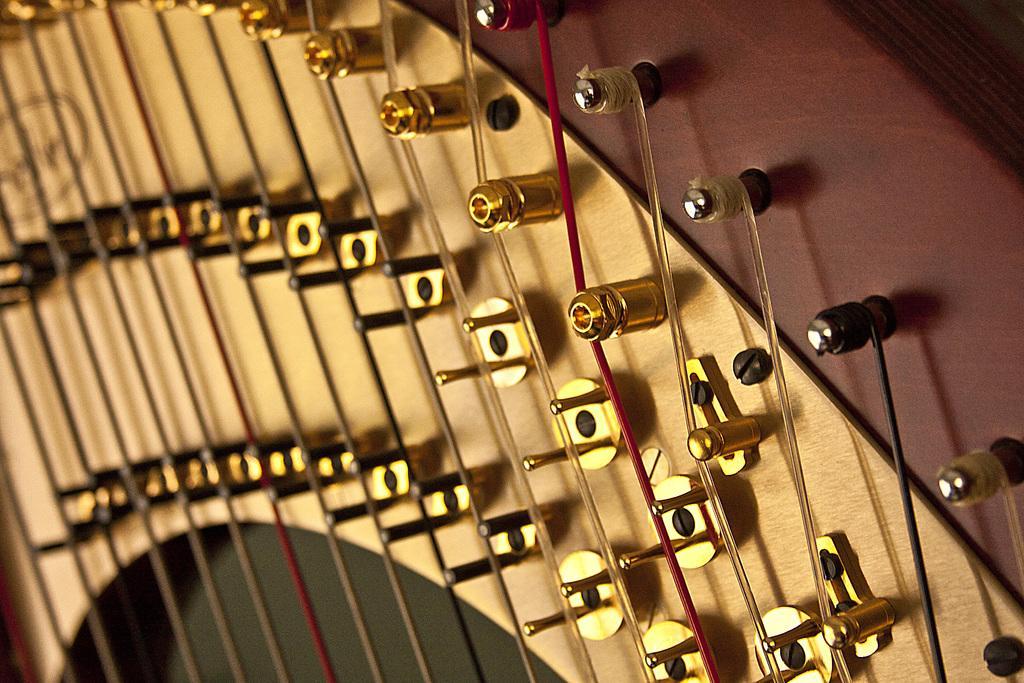How would you summarize this image in a sentence or two? In this image, there is a harp musical instrument with the strings. 